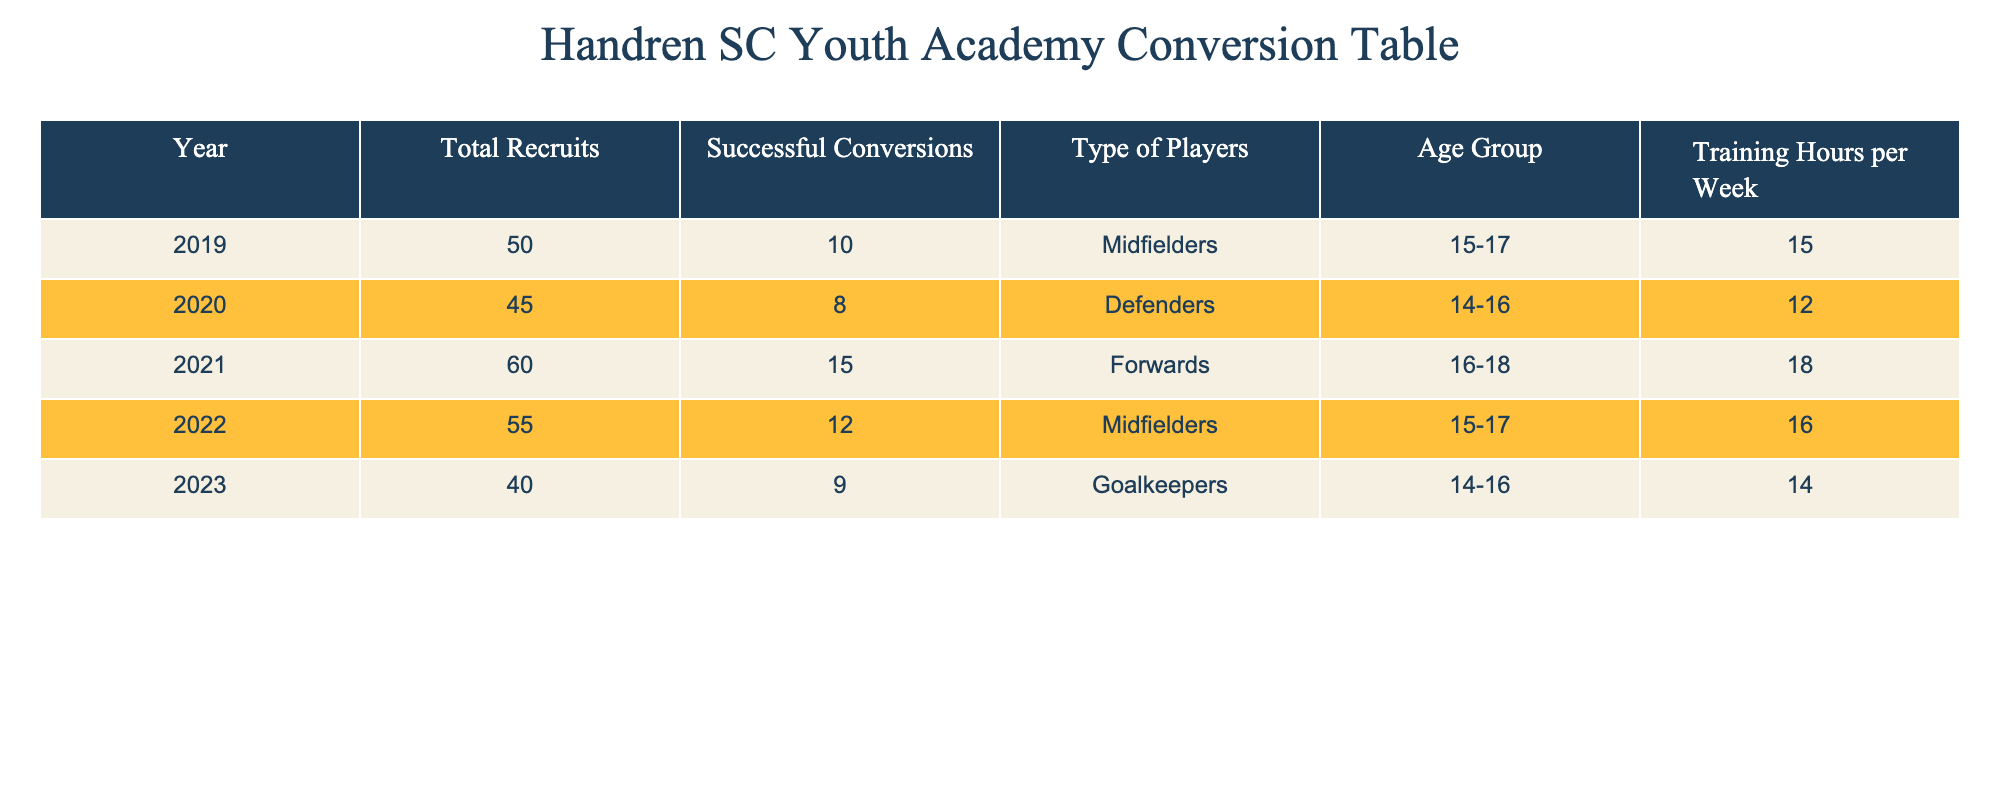What was the total number of recruits in 2021? Looking at the table, the column for 'Total Recruits' in the row for the year 2021 shows the value 60.
Answer: 60 How many successful conversions were there in 2020? In the table, the 'Successful Conversions' column for the year 2020 shows the value 8.
Answer: 8 Which type of players had the most successful conversions in 2019? The table indicates that in 2019, the type of players was 'Midfielders' with 10 successful conversions, which is the highest when comparing across types in that year.
Answer: Midfielders What is the average number of successful conversions over the five years? We sum the successful conversions: 10 + 8 + 15 + 12 + 9 = 54. There are 5 years, so the average is 54/5 = 10.8.
Answer: 10.8 In how many years were the training hours per week less than or equal to 15? Looking through the 'Training Hours per Week' column, 2019, 2020, and 2023 all have values of 15 or less. This gives a total of 3 years.
Answer: 3 Did Handren SC recruit more forwards than midfielders in 2022? In 2022, Handren SC recruited 12 midfielders and no forwards were recruited that year. Therefore, the statement is false.
Answer: No Which age group had the highest number of total recruits, and how many were there? By reviewing the 'Total Recruits' for each year and corresponding age groups, we see that 60 total recruits corresponds to the age group 16-18 in 2021, which is the highest.
Answer: 60, 16-18 How many successful conversions were there in the year with the least training hours? The year with the least training hours per week is 2020, which had 12 training hours. The successful conversions for that year were 8.
Answer: 8 What is the difference in total recruits between the years 2022 and 2019? Total recruits for 2022 is 55 and for 2019 is 50. The difference is 55 - 50 = 5.
Answer: 5 